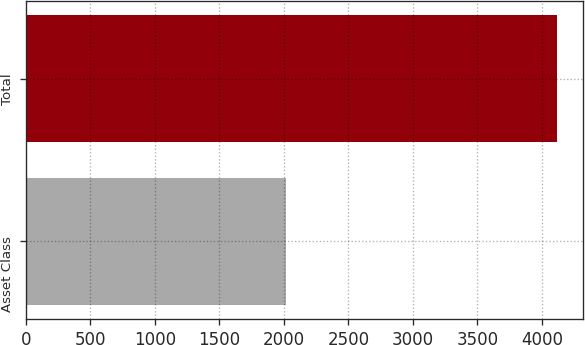Convert chart. <chart><loc_0><loc_0><loc_500><loc_500><bar_chart><fcel>Asset Class<fcel>Total<nl><fcel>2015<fcel>4113<nl></chart> 